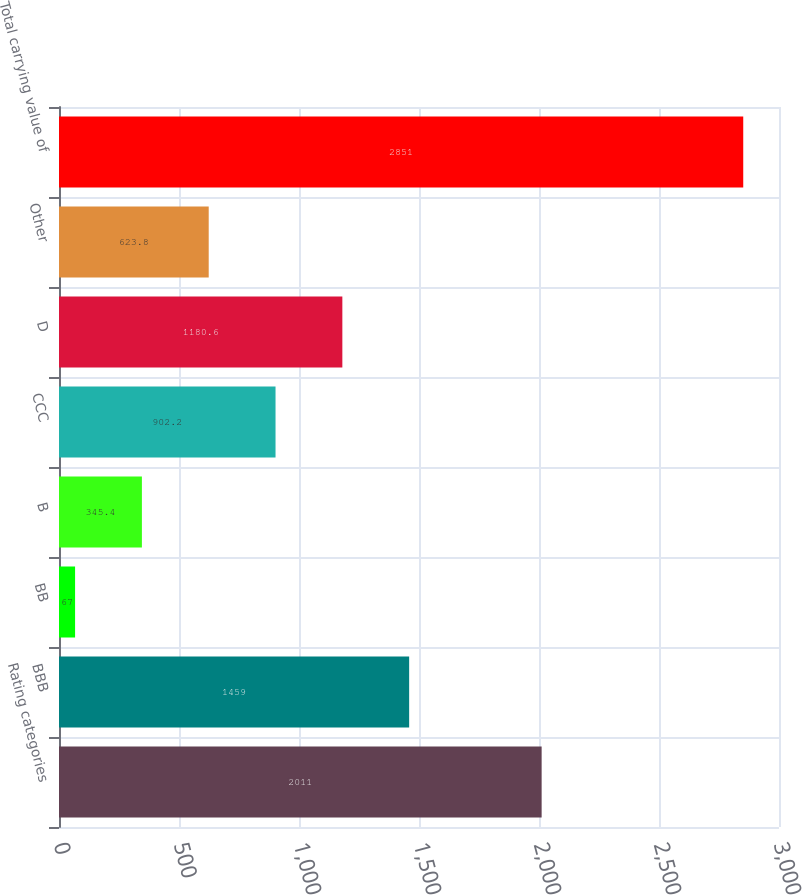Convert chart to OTSL. <chart><loc_0><loc_0><loc_500><loc_500><bar_chart><fcel>Rating categories<fcel>BBB<fcel>BB<fcel>B<fcel>CCC<fcel>D<fcel>Other<fcel>Total carrying value of<nl><fcel>2011<fcel>1459<fcel>67<fcel>345.4<fcel>902.2<fcel>1180.6<fcel>623.8<fcel>2851<nl></chart> 